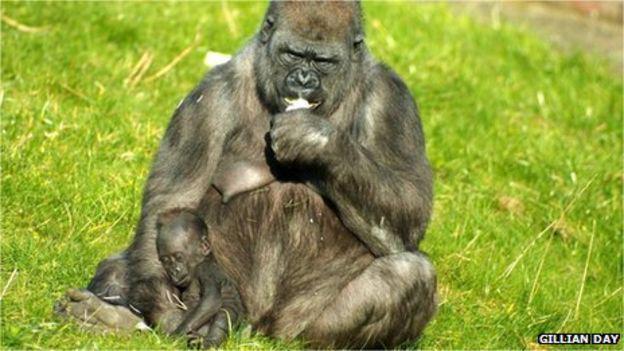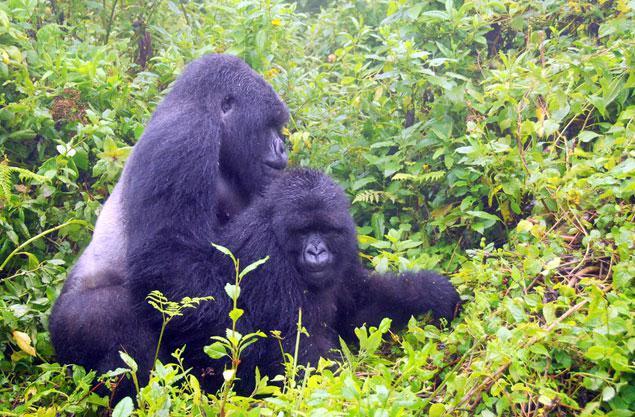The first image is the image on the left, the second image is the image on the right. Considering the images on both sides, is "There are at most two adult gorillas." valid? Answer yes or no. No. 